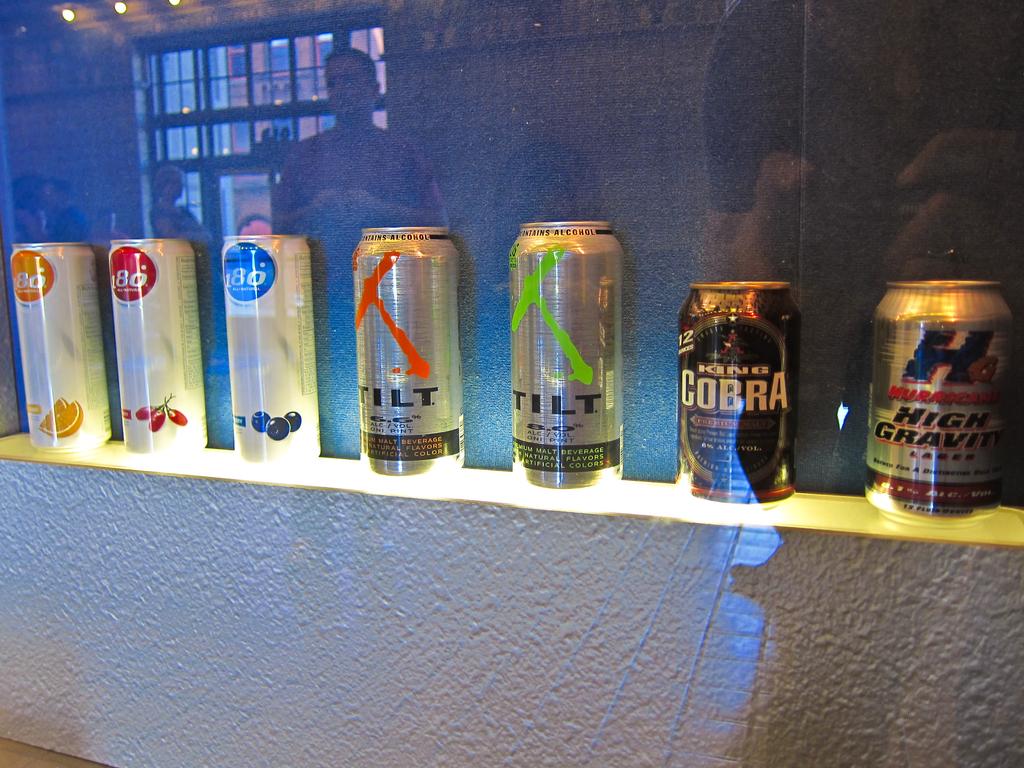What is the name of the second to the right drink?
Your response must be concise. Cobra. 